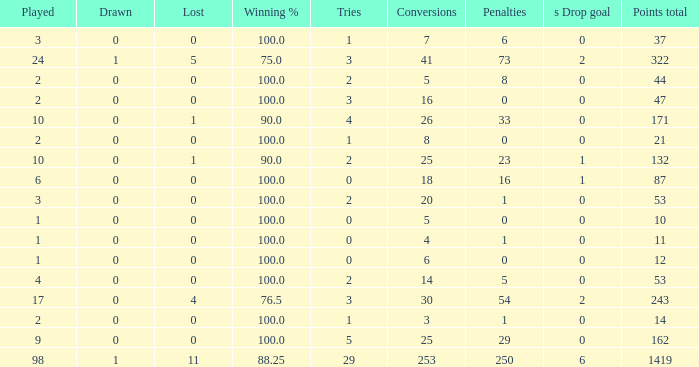What is the smallest amount of penalties he acquired when his points total was above 1419 in beyond 98 matches? None. 